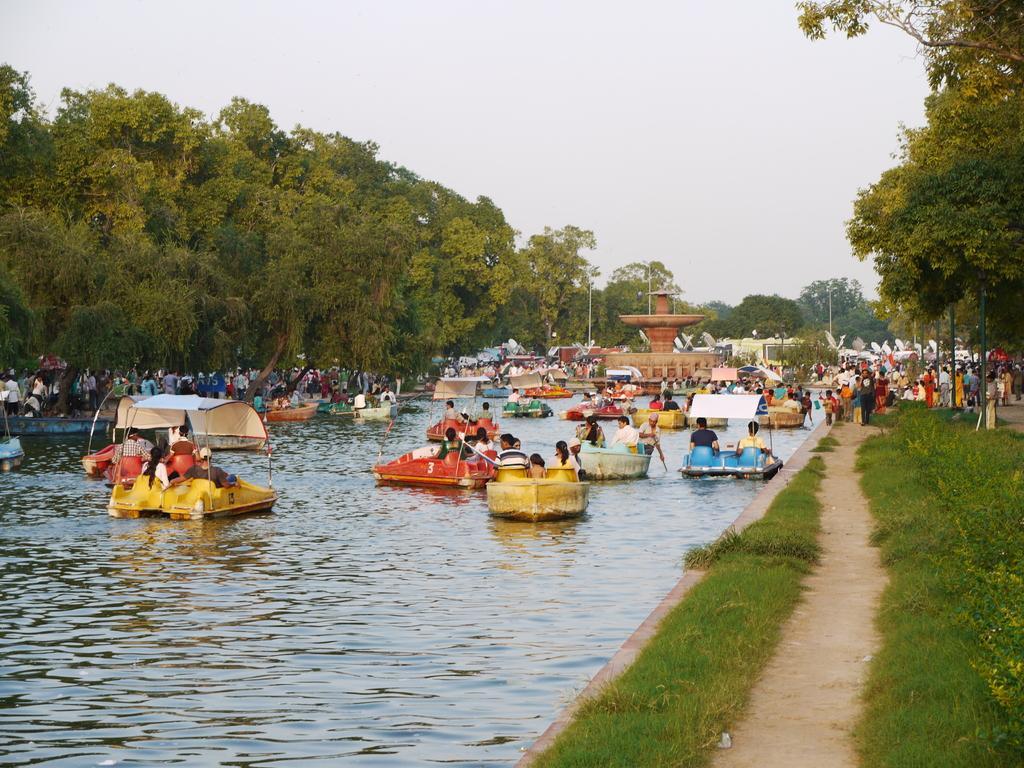In one or two sentences, can you explain what this image depicts? In this image, we can see water, there are some boats on the water, we can see some people sitting in the boats, there are some green trees, at the top there is a sky. 